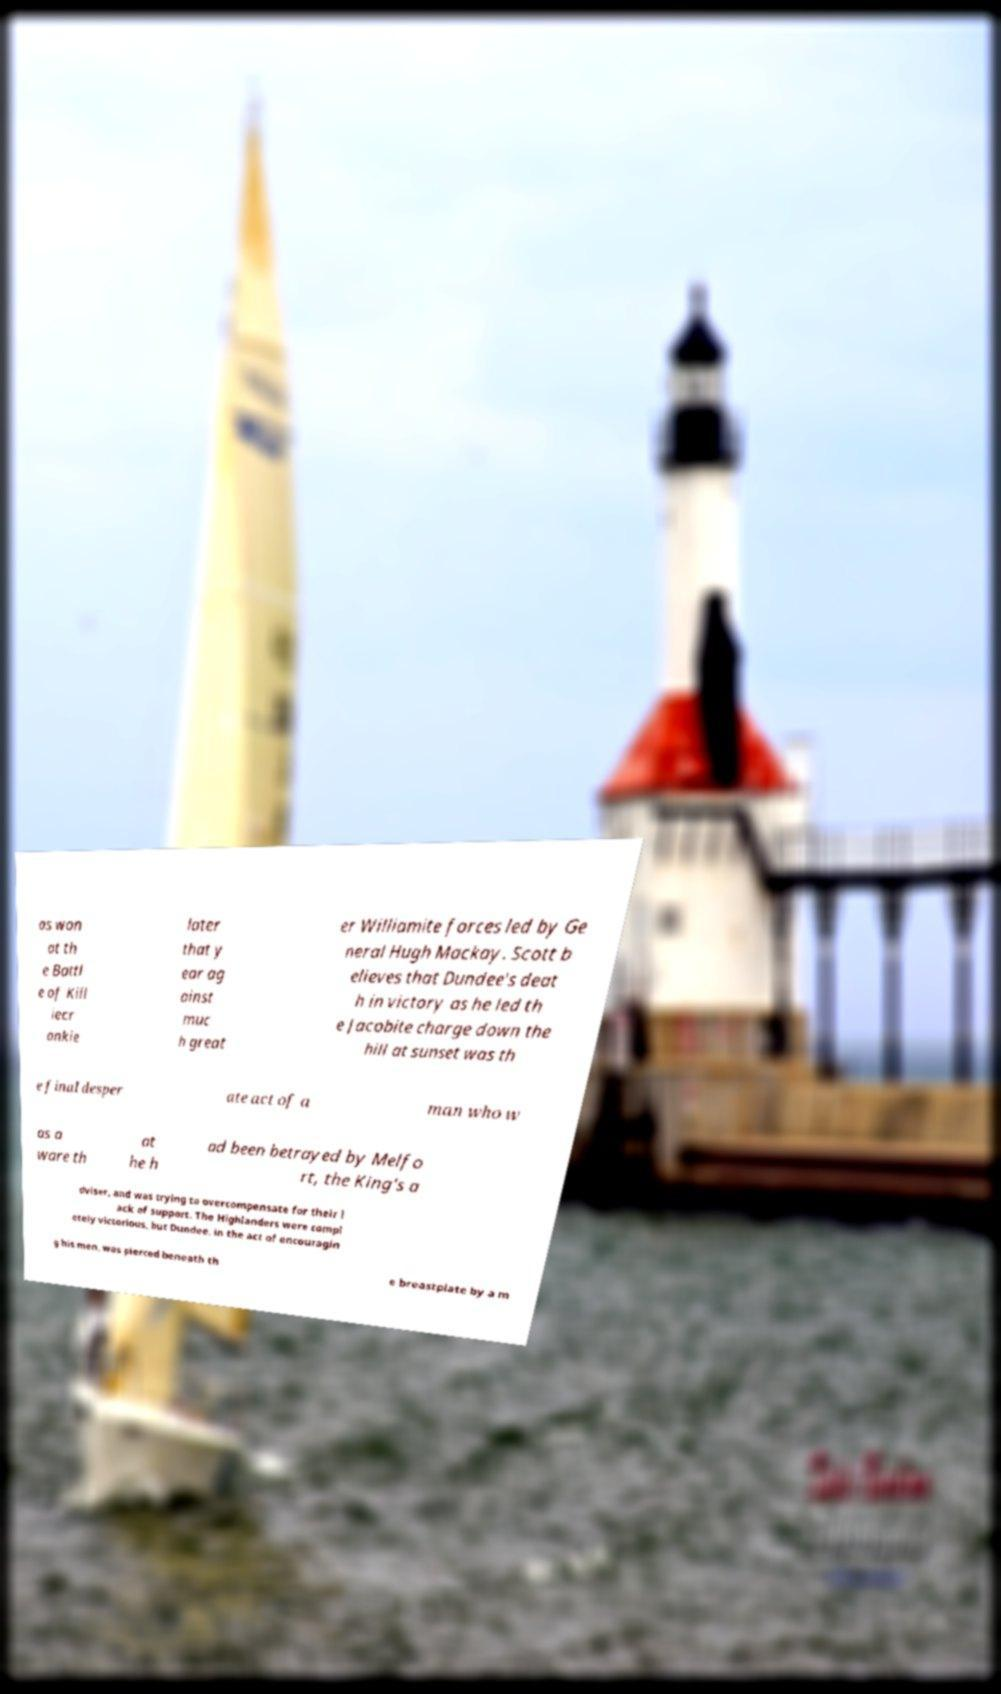Can you accurately transcribe the text from the provided image for me? as won at th e Battl e of Kill iecr ankie later that y ear ag ainst muc h great er Williamite forces led by Ge neral Hugh Mackay. Scott b elieves that Dundee's deat h in victory as he led th e Jacobite charge down the hill at sunset was th e final desper ate act of a man who w as a ware th at he h ad been betrayed by Melfo rt, the King's a dviser, and was trying to overcompensate for their l ack of support. The Highlanders were compl etely victorious, but Dundee, in the act of encouragin g his men, was pierced beneath th e breastplate by a m 